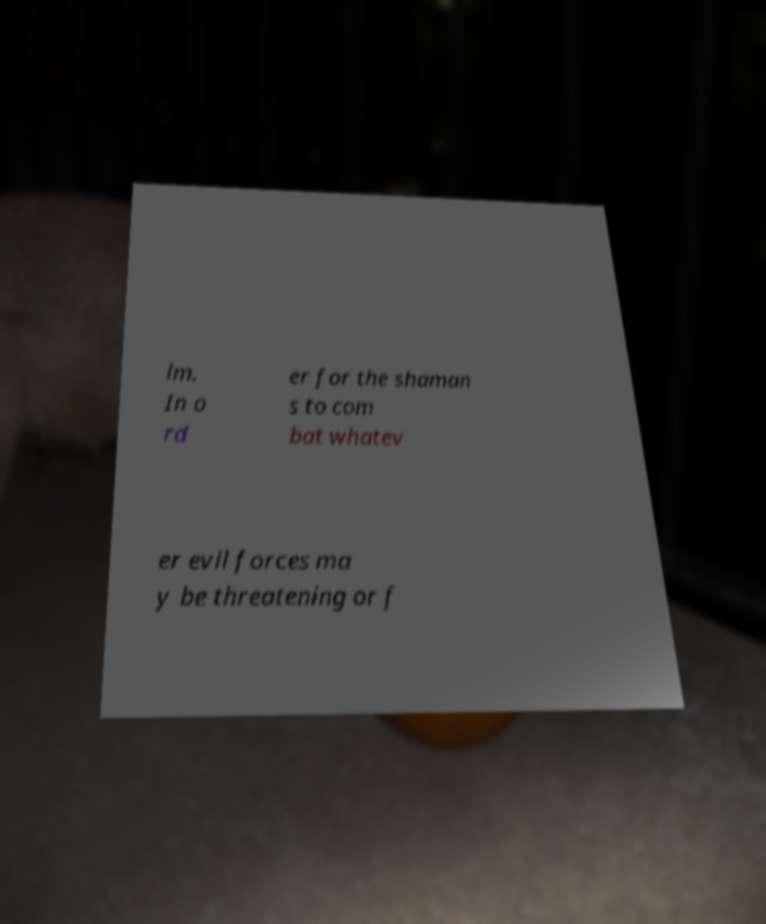There's text embedded in this image that I need extracted. Can you transcribe it verbatim? lm. In o rd er for the shaman s to com bat whatev er evil forces ma y be threatening or f 